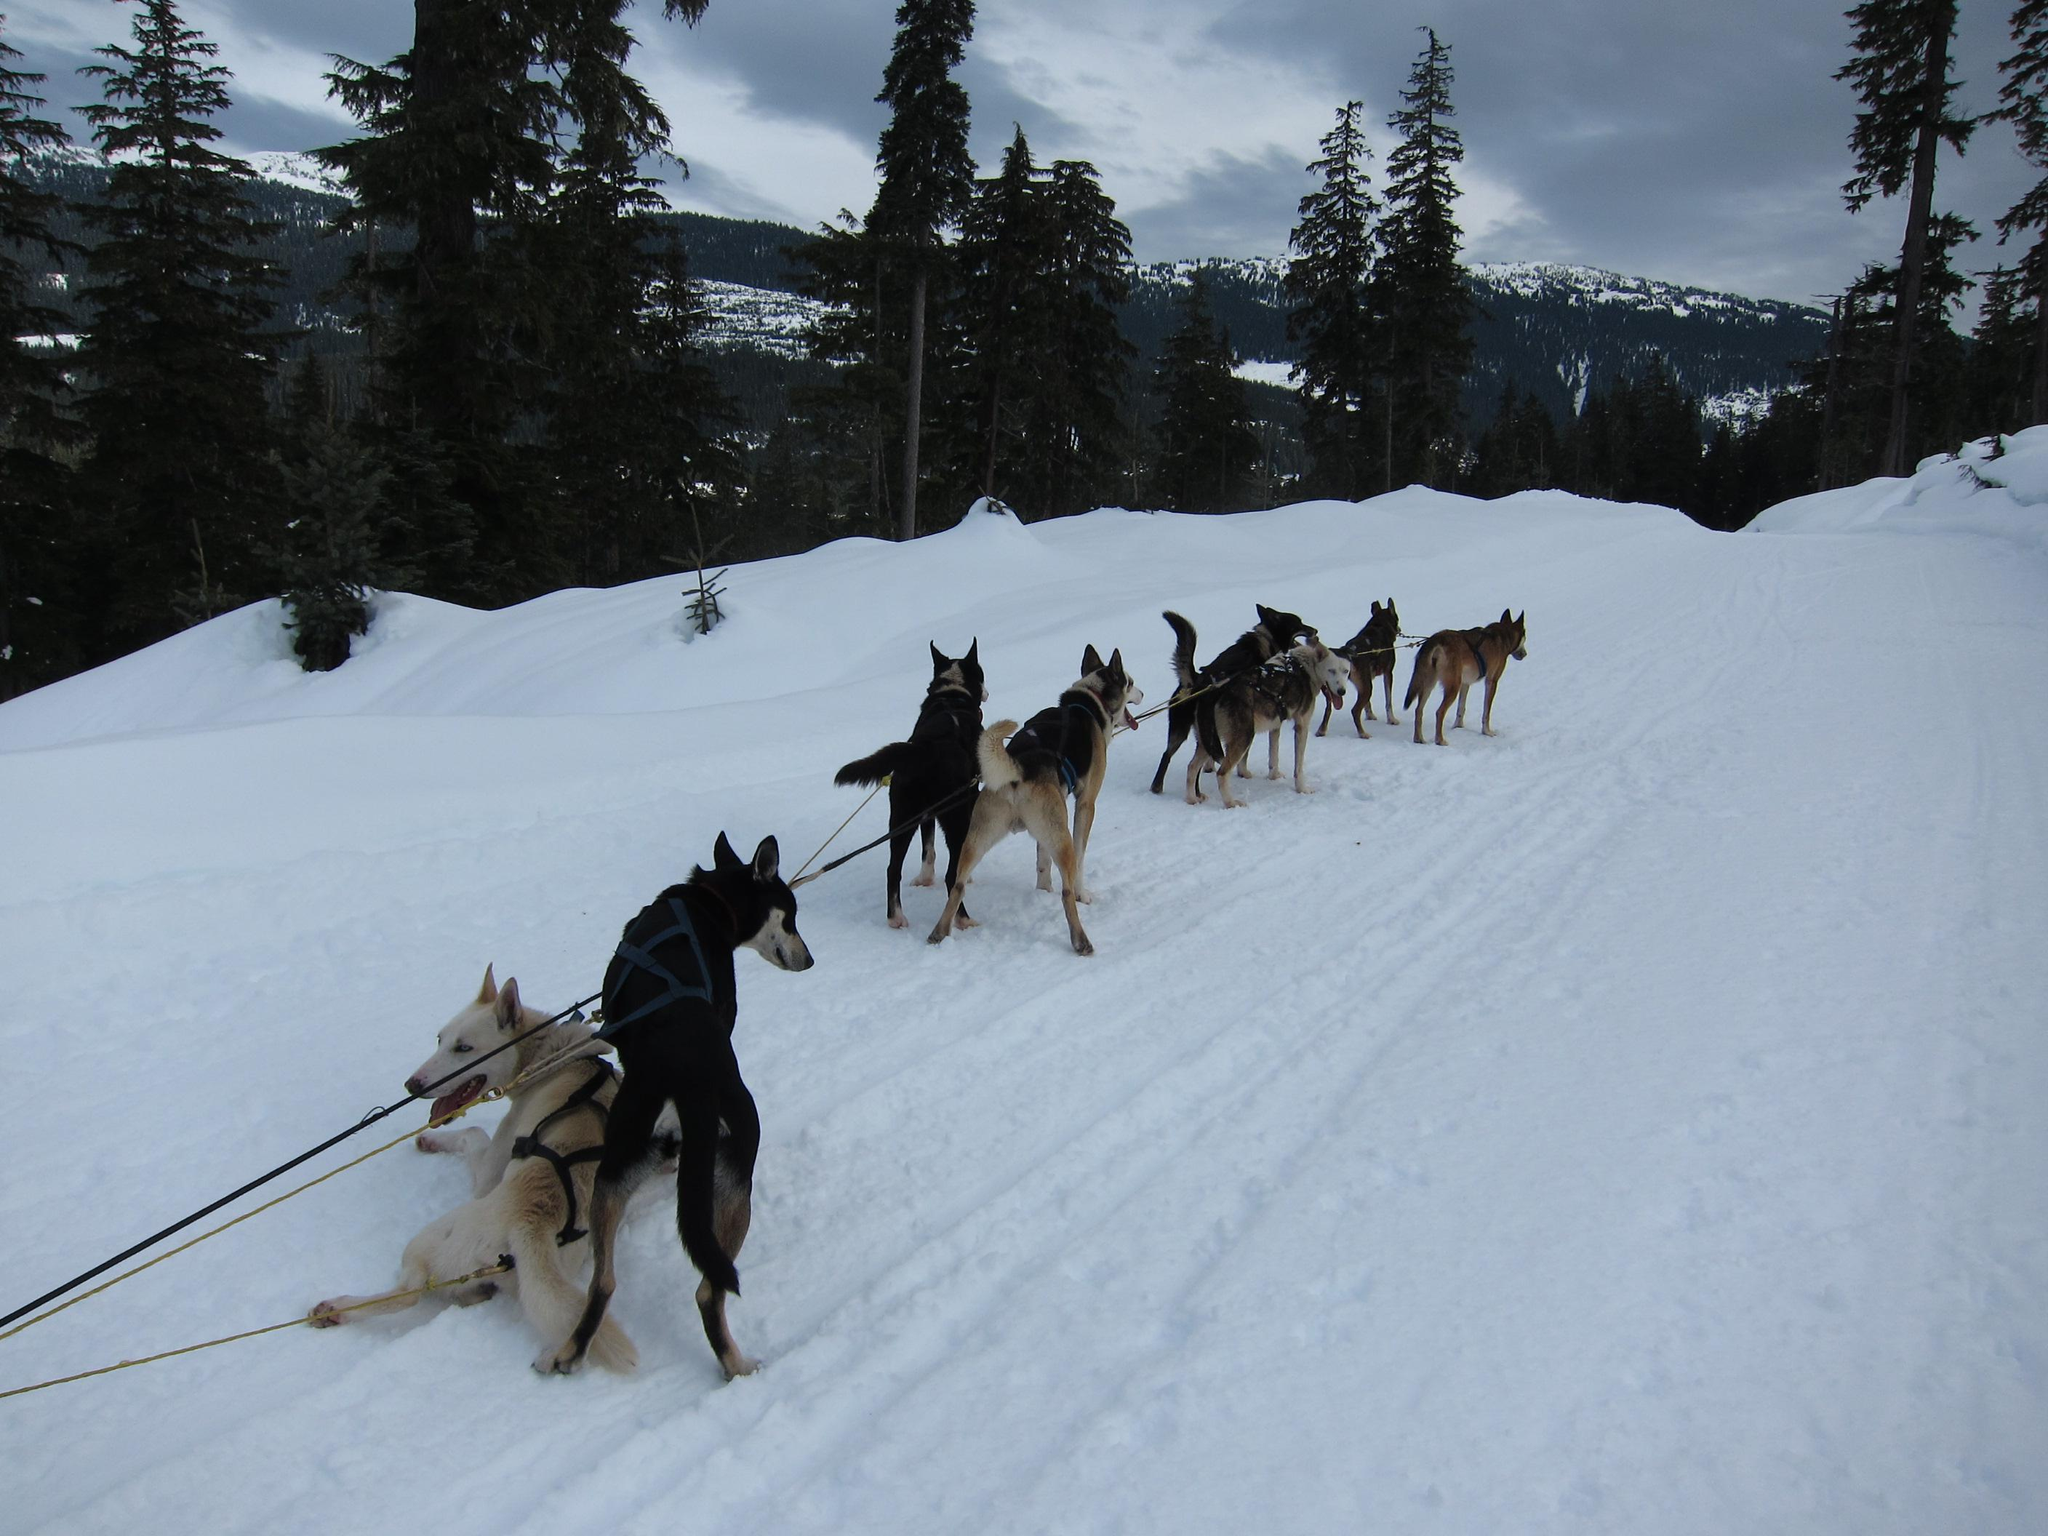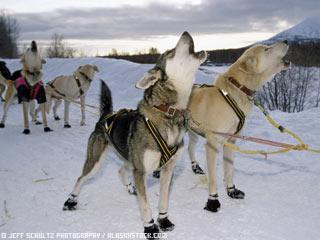The first image is the image on the left, the second image is the image on the right. Evaluate the accuracy of this statement regarding the images: "In at least one photo, the dogs are running.". Is it true? Answer yes or no. No. The first image is the image on the left, the second image is the image on the right. For the images shown, is this caption "There are no more than 2 people present, dog sledding." true? Answer yes or no. No. 